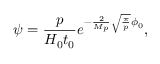<formula> <loc_0><loc_0><loc_500><loc_500>\psi = \frac { p } { H _ { 0 } t _ { 0 } } e ^ { - \frac { 2 } { M _ { p } } \sqrt { \frac { \pi } { p } } \phi _ { 0 } } ,</formula> 